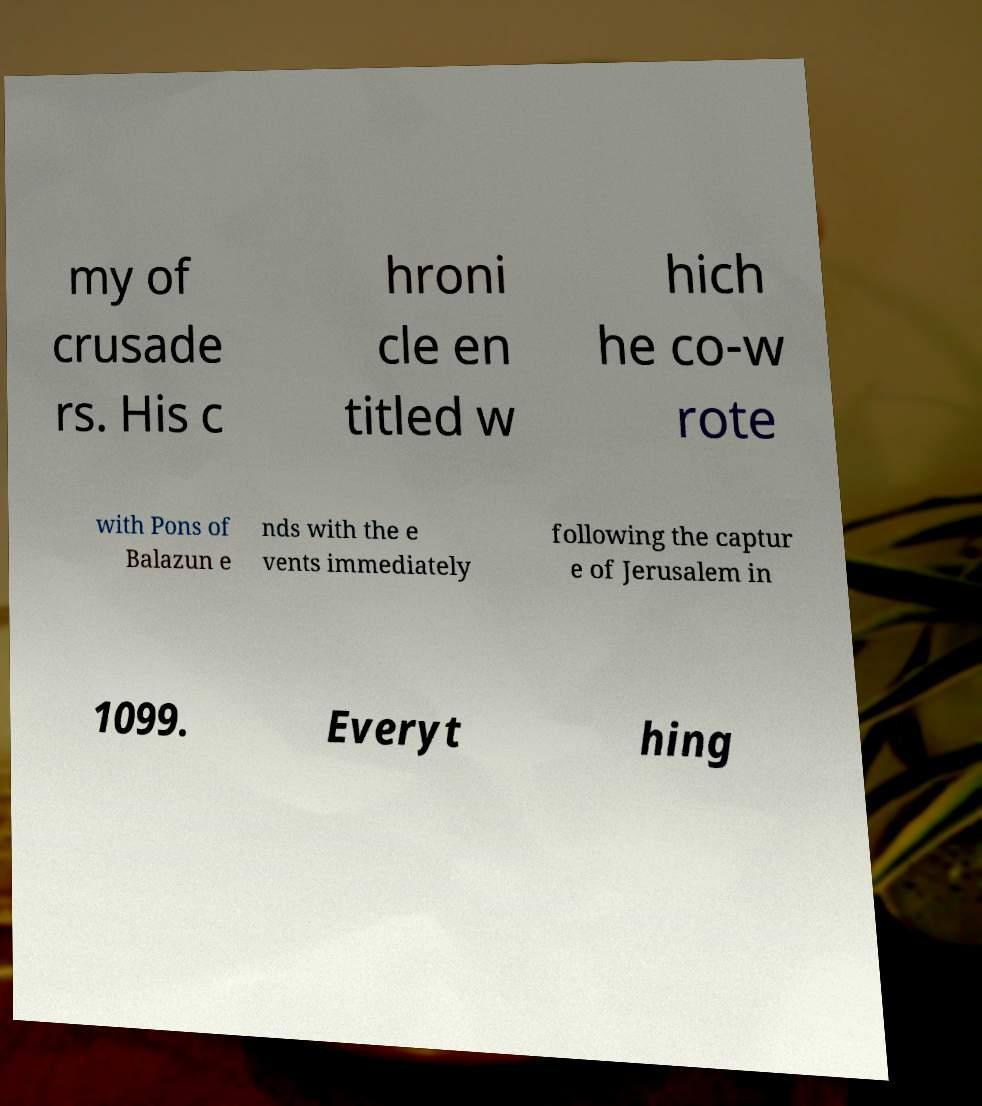Could you extract and type out the text from this image? my of crusade rs. His c hroni cle en titled w hich he co-w rote with Pons of Balazun e nds with the e vents immediately following the captur e of Jerusalem in 1099. Everyt hing 